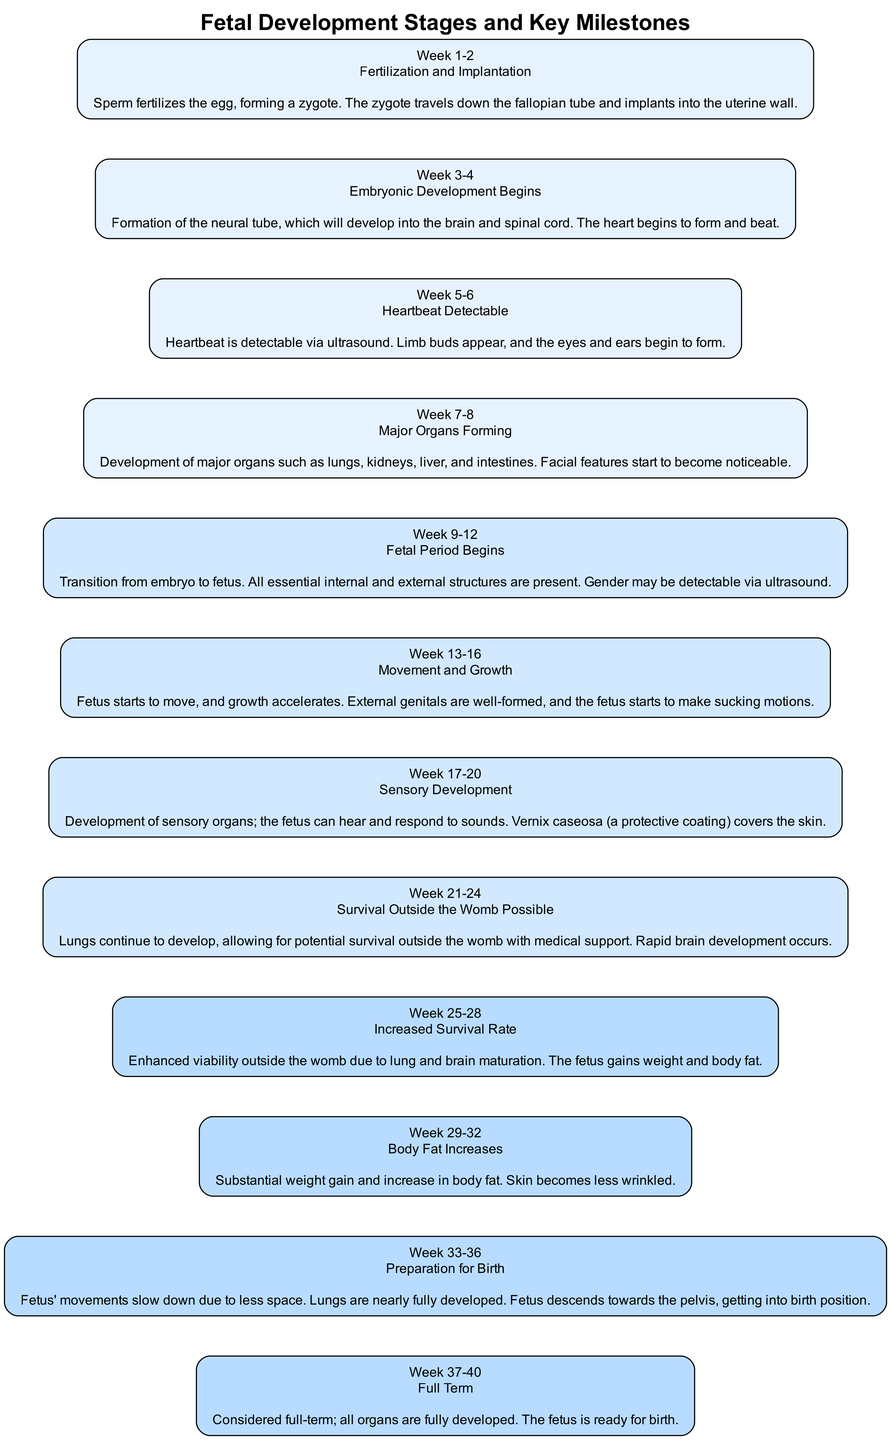What is the first milestone in fetal development? The first milestone is defined as the fertilization and implantation stage. This corresponds to the earliest two weeks where the sperm fertilizes the egg and the zygote implants in the uterine wall.
Answer: Fertilization and Implantation How many stages are there in the diagram? By counting each of the developmental stages represented in the structure, there are a total of 12 stages from fertilization to full term.
Answer: 12 At what week does the "Heartbeat Detectable" milestone occur? The "Heartbeat Detectable" milestone happens during weeks 5-6 of fetal development, according to the annotations provided.
Answer: Week 5-6 What happens during weeks 21-24? During weeks 21-24, it is noted that the lungs continue to develop, enabling potential survival outside the womb with medical support, and rapid brain development occurs.
Answer: Survival Outside the Womb Possible Which milestone indicates the transition from embryo to fetus? The transition from embryo to fetus is indicated during weeks 9-12, where all essential structures are present and gender may be detectable via ultrasound.
Answer: Fetal Period Begins What major organ develops during weeks 7-8? The development of major organs such as lungs, kidneys, liver, and intestines is highlighted during weeks 7-8, which signifies significant progress in fetal growth.
Answer: Major Organs Forming What occurs at the stage labeled "Full Term"? In the "Full Term" stage, which spans weeks 37-40, it is stated that all organs are fully developed, and the fetus is ready for birth.
Answer: All organs fully developed At what stage does the fetus start to make sucking motions? The stage where the fetus starts to make sucking motions is identified during weeks 13-16, characterized by movement and growth.
Answer: Movement and Growth What protective coating covers the skin during weeks 17-20? The protective coating covering the skin during weeks 17-20 is known as vernix caseosa, which helps protect the fetus's skin in amniotic fluid.
Answer: Vernix caseosa 